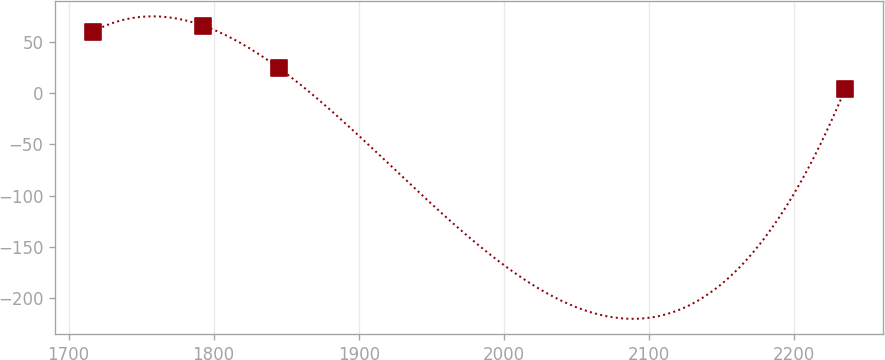Convert chart. <chart><loc_0><loc_0><loc_500><loc_500><line_chart><ecel><fcel>Unnamed: 1<nl><fcel>1716.64<fcel>60.3<nl><fcel>1792.87<fcel>66.13<nl><fcel>1844.74<fcel>24.97<nl><fcel>2235.3<fcel>4.44<nl></chart> 